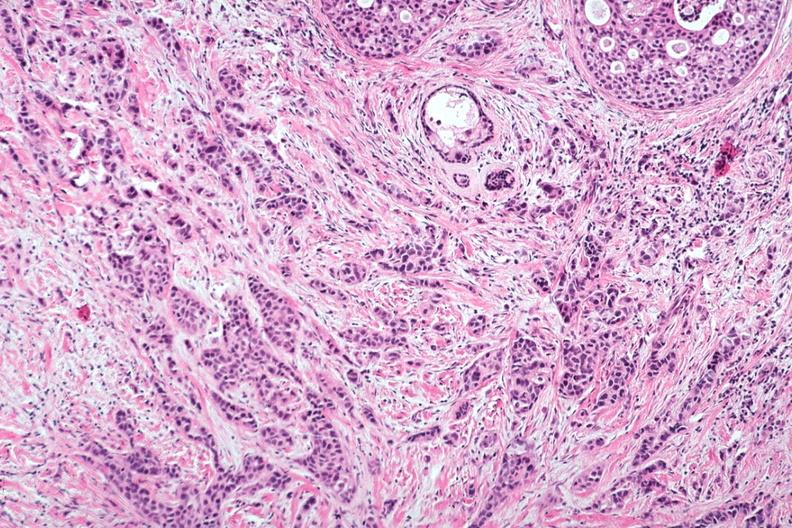what are seen?
Answer the question using a single word or phrase. Intraductal lesions 